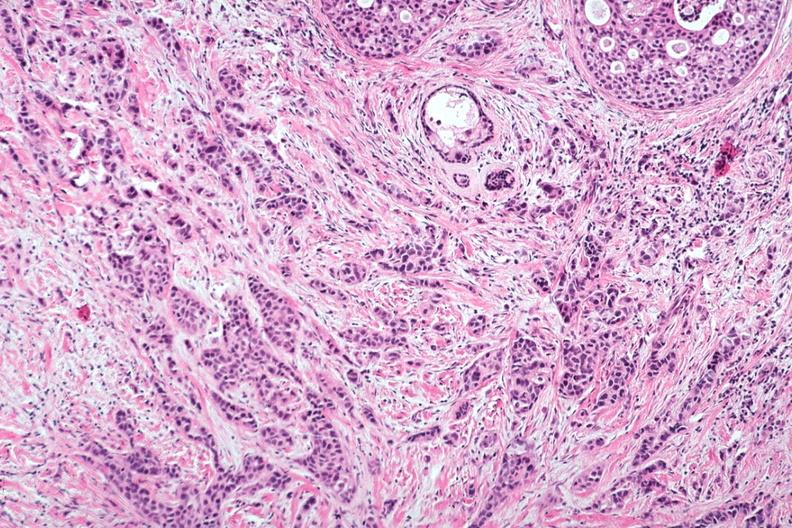what are seen?
Answer the question using a single word or phrase. Intraductal lesions 